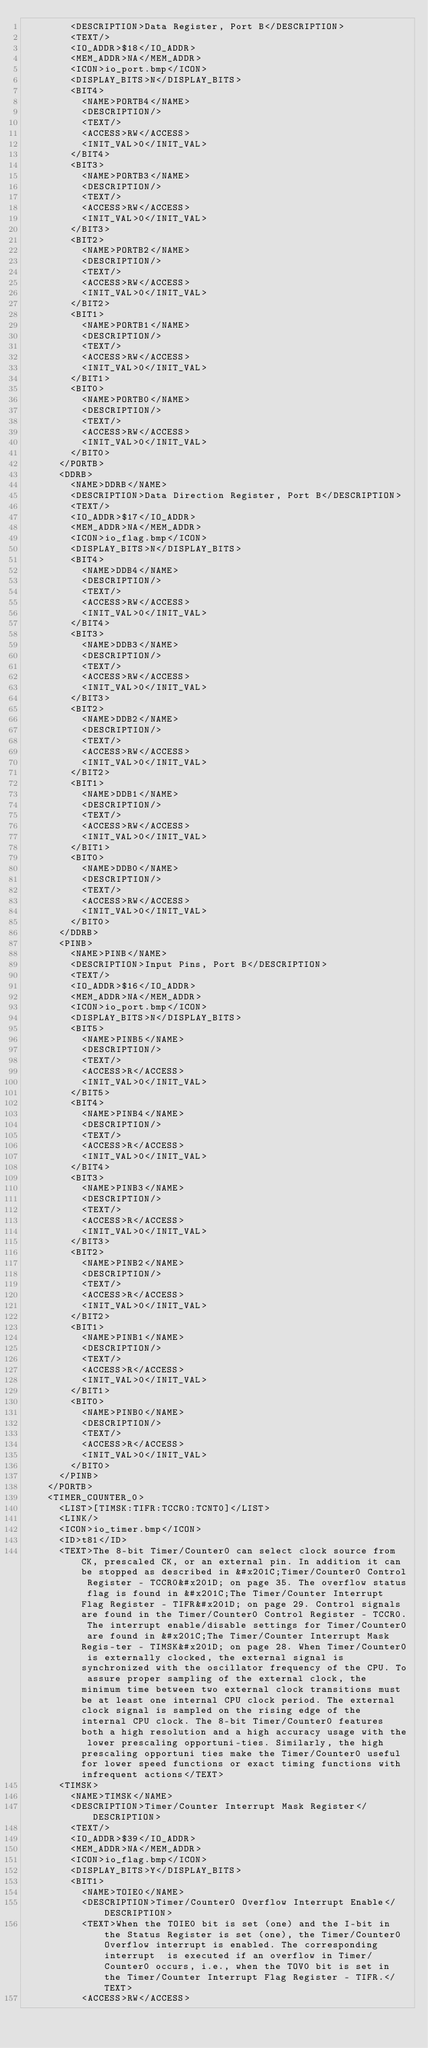Convert code to text. <code><loc_0><loc_0><loc_500><loc_500><_XML_>        <DESCRIPTION>Data Register, Port B</DESCRIPTION>
        <TEXT/>
        <IO_ADDR>$18</IO_ADDR>
        <MEM_ADDR>NA</MEM_ADDR>
        <ICON>io_port.bmp</ICON>
        <DISPLAY_BITS>N</DISPLAY_BITS>
        <BIT4>
          <NAME>PORTB4</NAME>
          <DESCRIPTION/>
          <TEXT/>
          <ACCESS>RW</ACCESS>
          <INIT_VAL>0</INIT_VAL>
        </BIT4>
        <BIT3>
          <NAME>PORTB3</NAME>
          <DESCRIPTION/>
          <TEXT/>
          <ACCESS>RW</ACCESS>
          <INIT_VAL>0</INIT_VAL>
        </BIT3>
        <BIT2>
          <NAME>PORTB2</NAME>
          <DESCRIPTION/>
          <TEXT/>
          <ACCESS>RW</ACCESS>
          <INIT_VAL>0</INIT_VAL>
        </BIT2>
        <BIT1>
          <NAME>PORTB1</NAME>
          <DESCRIPTION/>
          <TEXT/>
          <ACCESS>RW</ACCESS>
          <INIT_VAL>0</INIT_VAL>
        </BIT1>
        <BIT0>
          <NAME>PORTB0</NAME>
          <DESCRIPTION/>
          <TEXT/>
          <ACCESS>RW</ACCESS>
          <INIT_VAL>0</INIT_VAL>
        </BIT0>
      </PORTB>
      <DDRB>
        <NAME>DDRB</NAME>
        <DESCRIPTION>Data Direction Register, Port B</DESCRIPTION>
        <TEXT/>
        <IO_ADDR>$17</IO_ADDR>
        <MEM_ADDR>NA</MEM_ADDR>
        <ICON>io_flag.bmp</ICON>
        <DISPLAY_BITS>N</DISPLAY_BITS>
        <BIT4>
          <NAME>DDB4</NAME>
          <DESCRIPTION/>
          <TEXT/>
          <ACCESS>RW</ACCESS>
          <INIT_VAL>0</INIT_VAL>
        </BIT4>
        <BIT3>
          <NAME>DDB3</NAME>
          <DESCRIPTION/>
          <TEXT/>
          <ACCESS>RW</ACCESS>
          <INIT_VAL>0</INIT_VAL>
        </BIT3>
        <BIT2>
          <NAME>DDB2</NAME>
          <DESCRIPTION/>
          <TEXT/>
          <ACCESS>RW</ACCESS>
          <INIT_VAL>0</INIT_VAL>
        </BIT2>
        <BIT1>
          <NAME>DDB1</NAME>
          <DESCRIPTION/>
          <TEXT/>
          <ACCESS>RW</ACCESS>
          <INIT_VAL>0</INIT_VAL>
        </BIT1>
        <BIT0>
          <NAME>DDB0</NAME>
          <DESCRIPTION/>
          <TEXT/>
          <ACCESS>RW</ACCESS>
          <INIT_VAL>0</INIT_VAL>
        </BIT0>
      </DDRB>
      <PINB>
        <NAME>PINB</NAME>
        <DESCRIPTION>Input Pins, Port B</DESCRIPTION>
        <TEXT/>
        <IO_ADDR>$16</IO_ADDR>
        <MEM_ADDR>NA</MEM_ADDR>
        <ICON>io_port.bmp</ICON>
        <DISPLAY_BITS>N</DISPLAY_BITS>
        <BIT5>
          <NAME>PINB5</NAME>
          <DESCRIPTION/>
          <TEXT/>
          <ACCESS>R</ACCESS>
          <INIT_VAL>0</INIT_VAL>
        </BIT5>
        <BIT4>
          <NAME>PINB4</NAME>
          <DESCRIPTION/>
          <TEXT/>
          <ACCESS>R</ACCESS>
          <INIT_VAL>0</INIT_VAL>
        </BIT4>
        <BIT3>
          <NAME>PINB3</NAME>
          <DESCRIPTION/>
          <TEXT/>
          <ACCESS>R</ACCESS>
          <INIT_VAL>0</INIT_VAL>
        </BIT3>
        <BIT2>
          <NAME>PINB2</NAME>
          <DESCRIPTION/>
          <TEXT/>
          <ACCESS>R</ACCESS>
          <INIT_VAL>0</INIT_VAL>
        </BIT2>
        <BIT1>
          <NAME>PINB1</NAME>
          <DESCRIPTION/>
          <TEXT/>
          <ACCESS>R</ACCESS>
          <INIT_VAL>0</INIT_VAL>
        </BIT1>
        <BIT0>
          <NAME>PINB0</NAME>
          <DESCRIPTION/>
          <TEXT/>
          <ACCESS>R</ACCESS>
          <INIT_VAL>0</INIT_VAL>
        </BIT0>
      </PINB>
    </PORTB>
    <TIMER_COUNTER_0>
      <LIST>[TIMSK:TIFR:TCCR0:TCNT0]</LIST>
      <LINK/>
      <ICON>io_timer.bmp</ICON>
      <ID>t81</ID>
      <TEXT>The 8-bit Timer/Counter0 can select clock source from CK, prescaled CK, or an external pin. In addition it can be stopped as described in &#x201C;Timer/Counter0 Control Register - TCCR0&#x201D; on page 35. The overflow status flag is found in &#x201C;The Timer/Counter Interrupt Flag Register - TIFR&#x201D; on page 29. Control signals are found in the Timer/Counter0 Control Register - TCCR0. The interrupt enable/disable settings for Timer/Counter0 are found in &#x201C;The Timer/Counter Interrupt Mask Regis-ter - TIMSK&#x201D; on page 28. When Timer/Counter0 is externally clocked, the external signal is synchronized with the oscillator frequency of the CPU. To assure proper sampling of the external clock, the minimum time between two external clock transitions must be at least one internal CPU clock period. The external clock signal is sampled on the rising edge of the internal CPU clock. The 8-bit Timer/Counter0 features both a high resolution and a high accuracy usage with the lower prescaling opportuni-ties. Similarly, the high prescaling opportuni ties make the Timer/Counter0 useful for lower speed functions or exact timing functions with infrequent actions</TEXT>
      <TIMSK>
        <NAME>TIMSK</NAME>
        <DESCRIPTION>Timer/Counter Interrupt Mask Register</DESCRIPTION>
        <TEXT/>
        <IO_ADDR>$39</IO_ADDR>
        <MEM_ADDR>NA</MEM_ADDR>
        <ICON>io_flag.bmp</ICON>
        <DISPLAY_BITS>Y</DISPLAY_BITS>
        <BIT1>
          <NAME>TOIE0</NAME>
          <DESCRIPTION>Timer/Counter0 Overflow Interrupt Enable</DESCRIPTION>
          <TEXT>When the TOIE0 bit is set (one) and the I-bit in the Status Register is set (one), the Timer/Counter0 Overflow interrupt is enabled. The corresponding interrupt  is executed if an overflow in Timer/Counter0 occurs, i.e., when the TOV0 bit is set in the Timer/Counter Interrupt Flag Register - TIFR.</TEXT>
          <ACCESS>RW</ACCESS></code> 